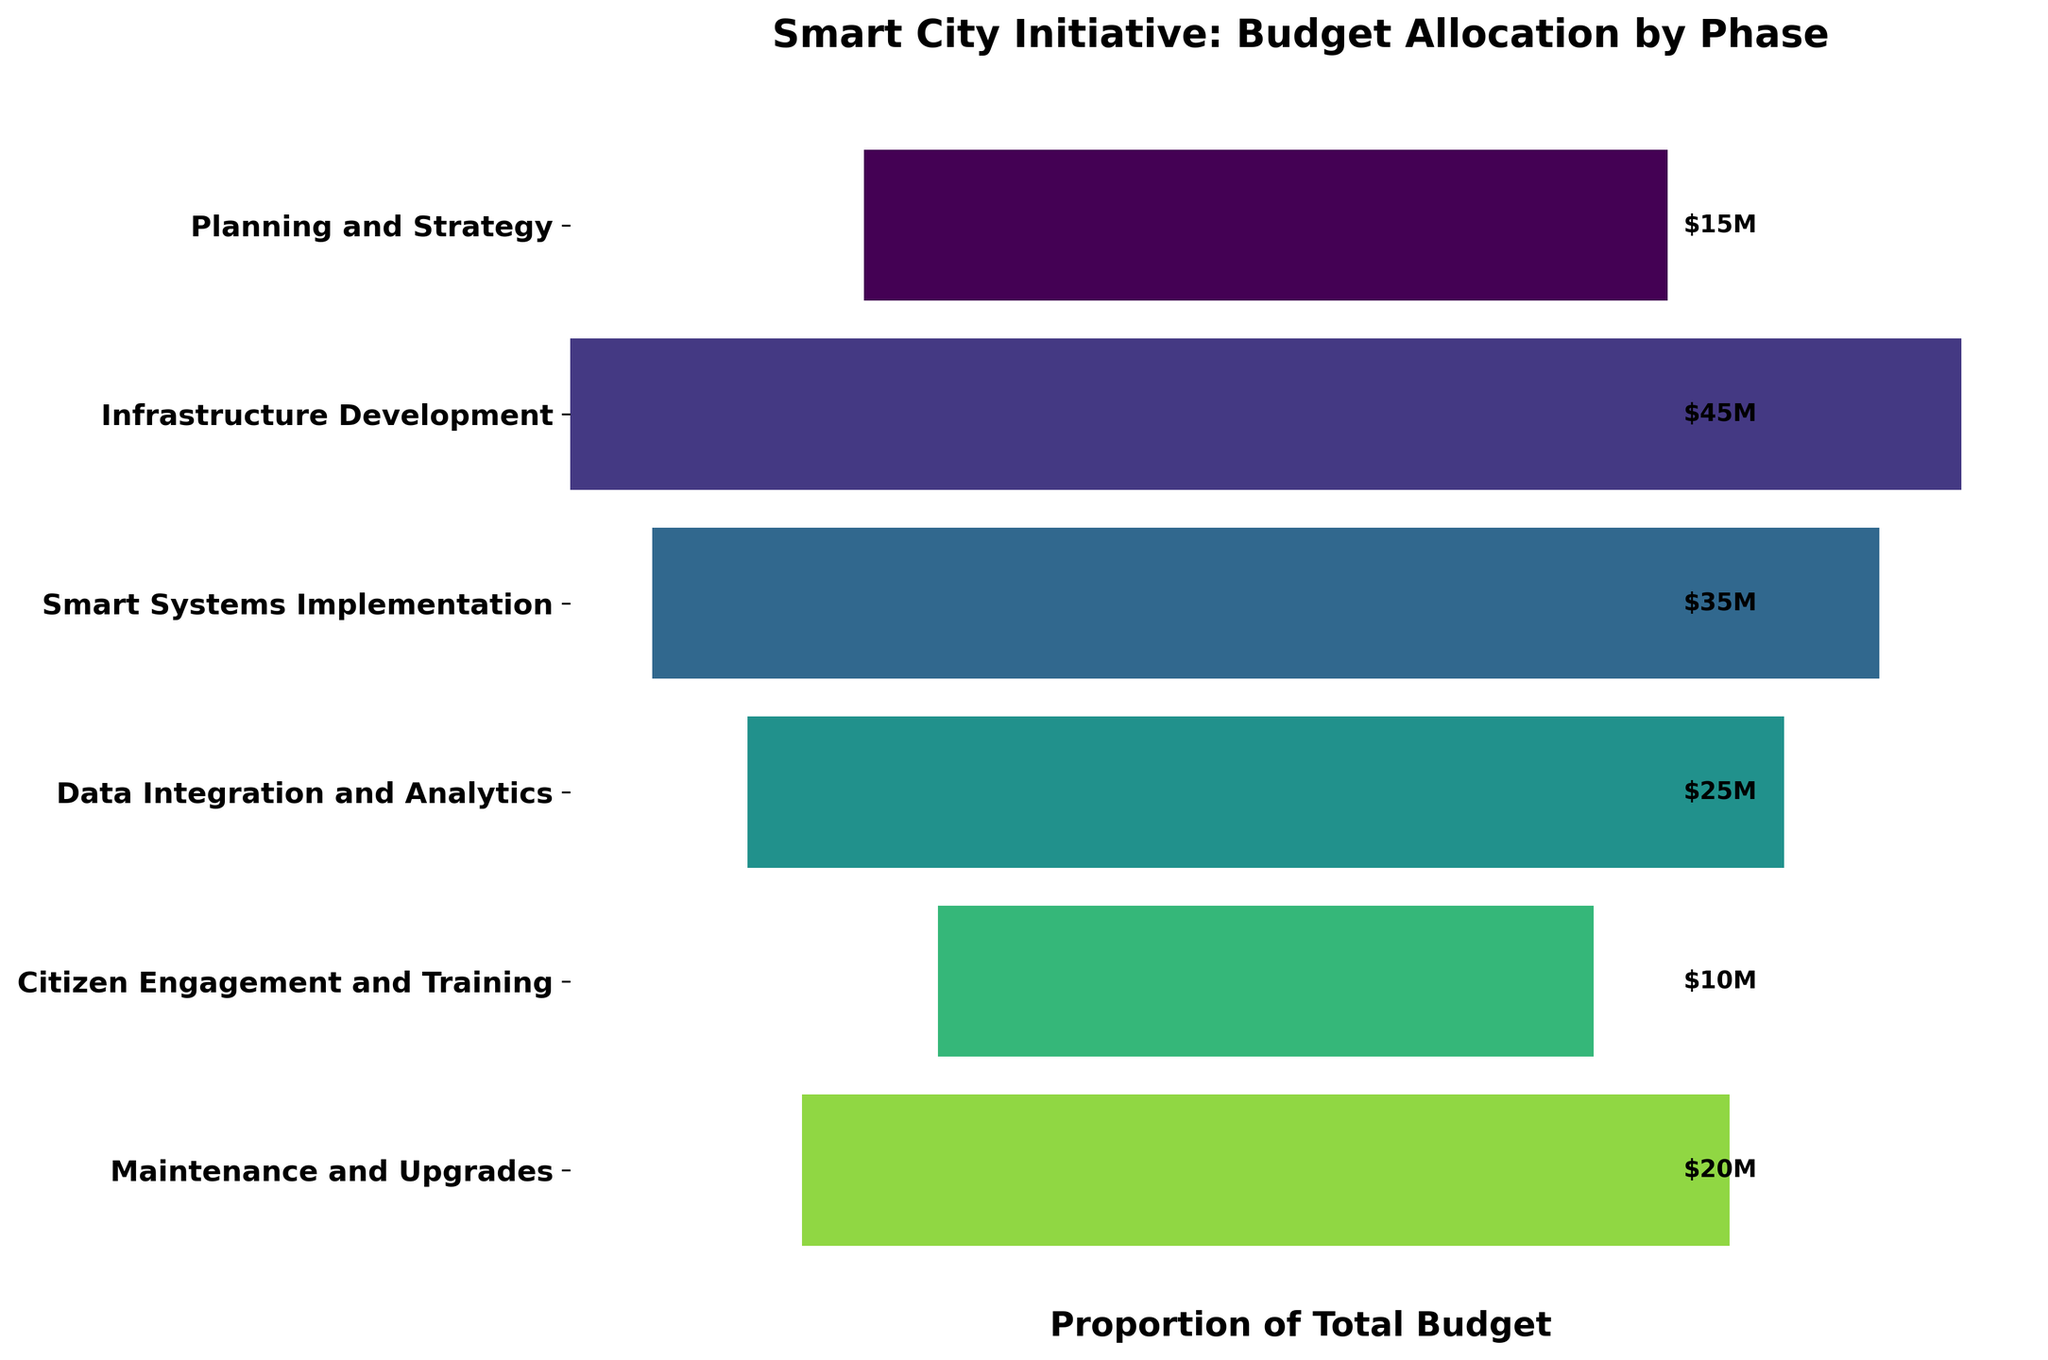What's the total budget allocated across all phases? Add the budget allocation for each phase: 15M (Planning and Strategy) + 45M (Infrastructure Development) + 35M (Smart Systems Implementation) + 25M (Data Integration and Analytics) + 10M (Citizen Engagement and Training) + 20M (Maintenance and Upgrades) = 150M
Answer: 150M Which phase has the highest budget allocation? Refer to the budget values labeled on the right of the figure. The highest budget allocation is 45M under the "Infrastructure Development" phase.
Answer: Infrastructure Development What is the average budget allocation per phase? Sum the budget allocations for all phases (15M + 45M + 35M + 25M + 10M + 20M = 150M) and divide by the number of phases (6), so 150M/6 = 25M
Answer: 25M How much more budget is allocated to Infrastructure Development than to Planning and Strategy? Subtract the budget for Planning and Strategy (15M) from the budget for Infrastructure Development (45M), which is 45M - 15M = 30M
Answer: 30M Which phase has the lowest budget allocation? Refer to the budget values labeled on the right of the figure. The lowest budget allocation is 10M under the "Citizen Engagement and Training" phase.
Answer: Citizen Engagement and Training What's the combined budget for the Implementation and Analytics phases? Add the budget allocation for "Smart Systems Implementation" (35M) and "Data Integration and Analytics" (25M): 35M + 25M = 60M
Answer: 60M How does the budget for Data Integration and Analytics compare to Maintenance and Upgrades? Compare the budget values, where Data Integration and Analytics is 25M and Maintenance and Upgrades is 20M. So, Data Integration and Analytics has a higher budget.
Answer: Data Integration and Analytics What percentage of the total budget is allocated to the Infrastructure Development phase? Calculate the total budget (150M), then divide the budget for Infrastructure Development (45M) by the total budget and multiply by 100: (45M / 150M) * 100 ≈ 30%
Answer: 30% What is the difference in budget allocation between the highest and lowest phases? Identify the highest (45M for Infrastructure Development) and lowest (10M for Citizen Engagement and Training) allocations, then subtract: 45M - 10M = 35M
Answer: 35M Arrange the phases in descending order based on their budget allocation. List the phases from highest to lowest budget allocation based on the budget values: Infrastructure Development (45M), Smart Systems Implementation (35M), Data Integration and Analytics (25M), Maintenance and Upgrades (20M), Planning and Strategy (15M), Citizen Engagement and Training (10M)
Answer: Infrastructure Development, Smart Systems Implementation, Data Integration and Analytics, Maintenance and Upgrades, Planning and Strategy, Citizen Engagement and Training 